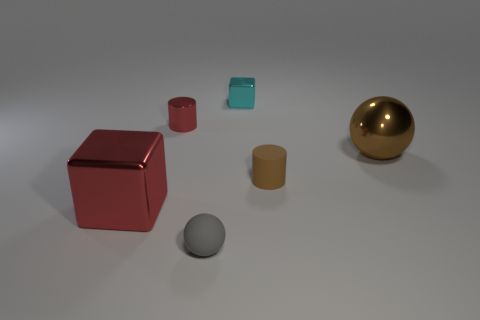Subtract all blue cubes. Subtract all green cylinders. How many cubes are left? 2 Add 2 red metal cubes. How many objects exist? 8 Add 5 brown shiny objects. How many brown shiny objects are left? 6 Add 1 metal cubes. How many metal cubes exist? 3 Subtract 0 gray cylinders. How many objects are left? 6 Subtract all small purple balls. Subtract all tiny red metal cylinders. How many objects are left? 5 